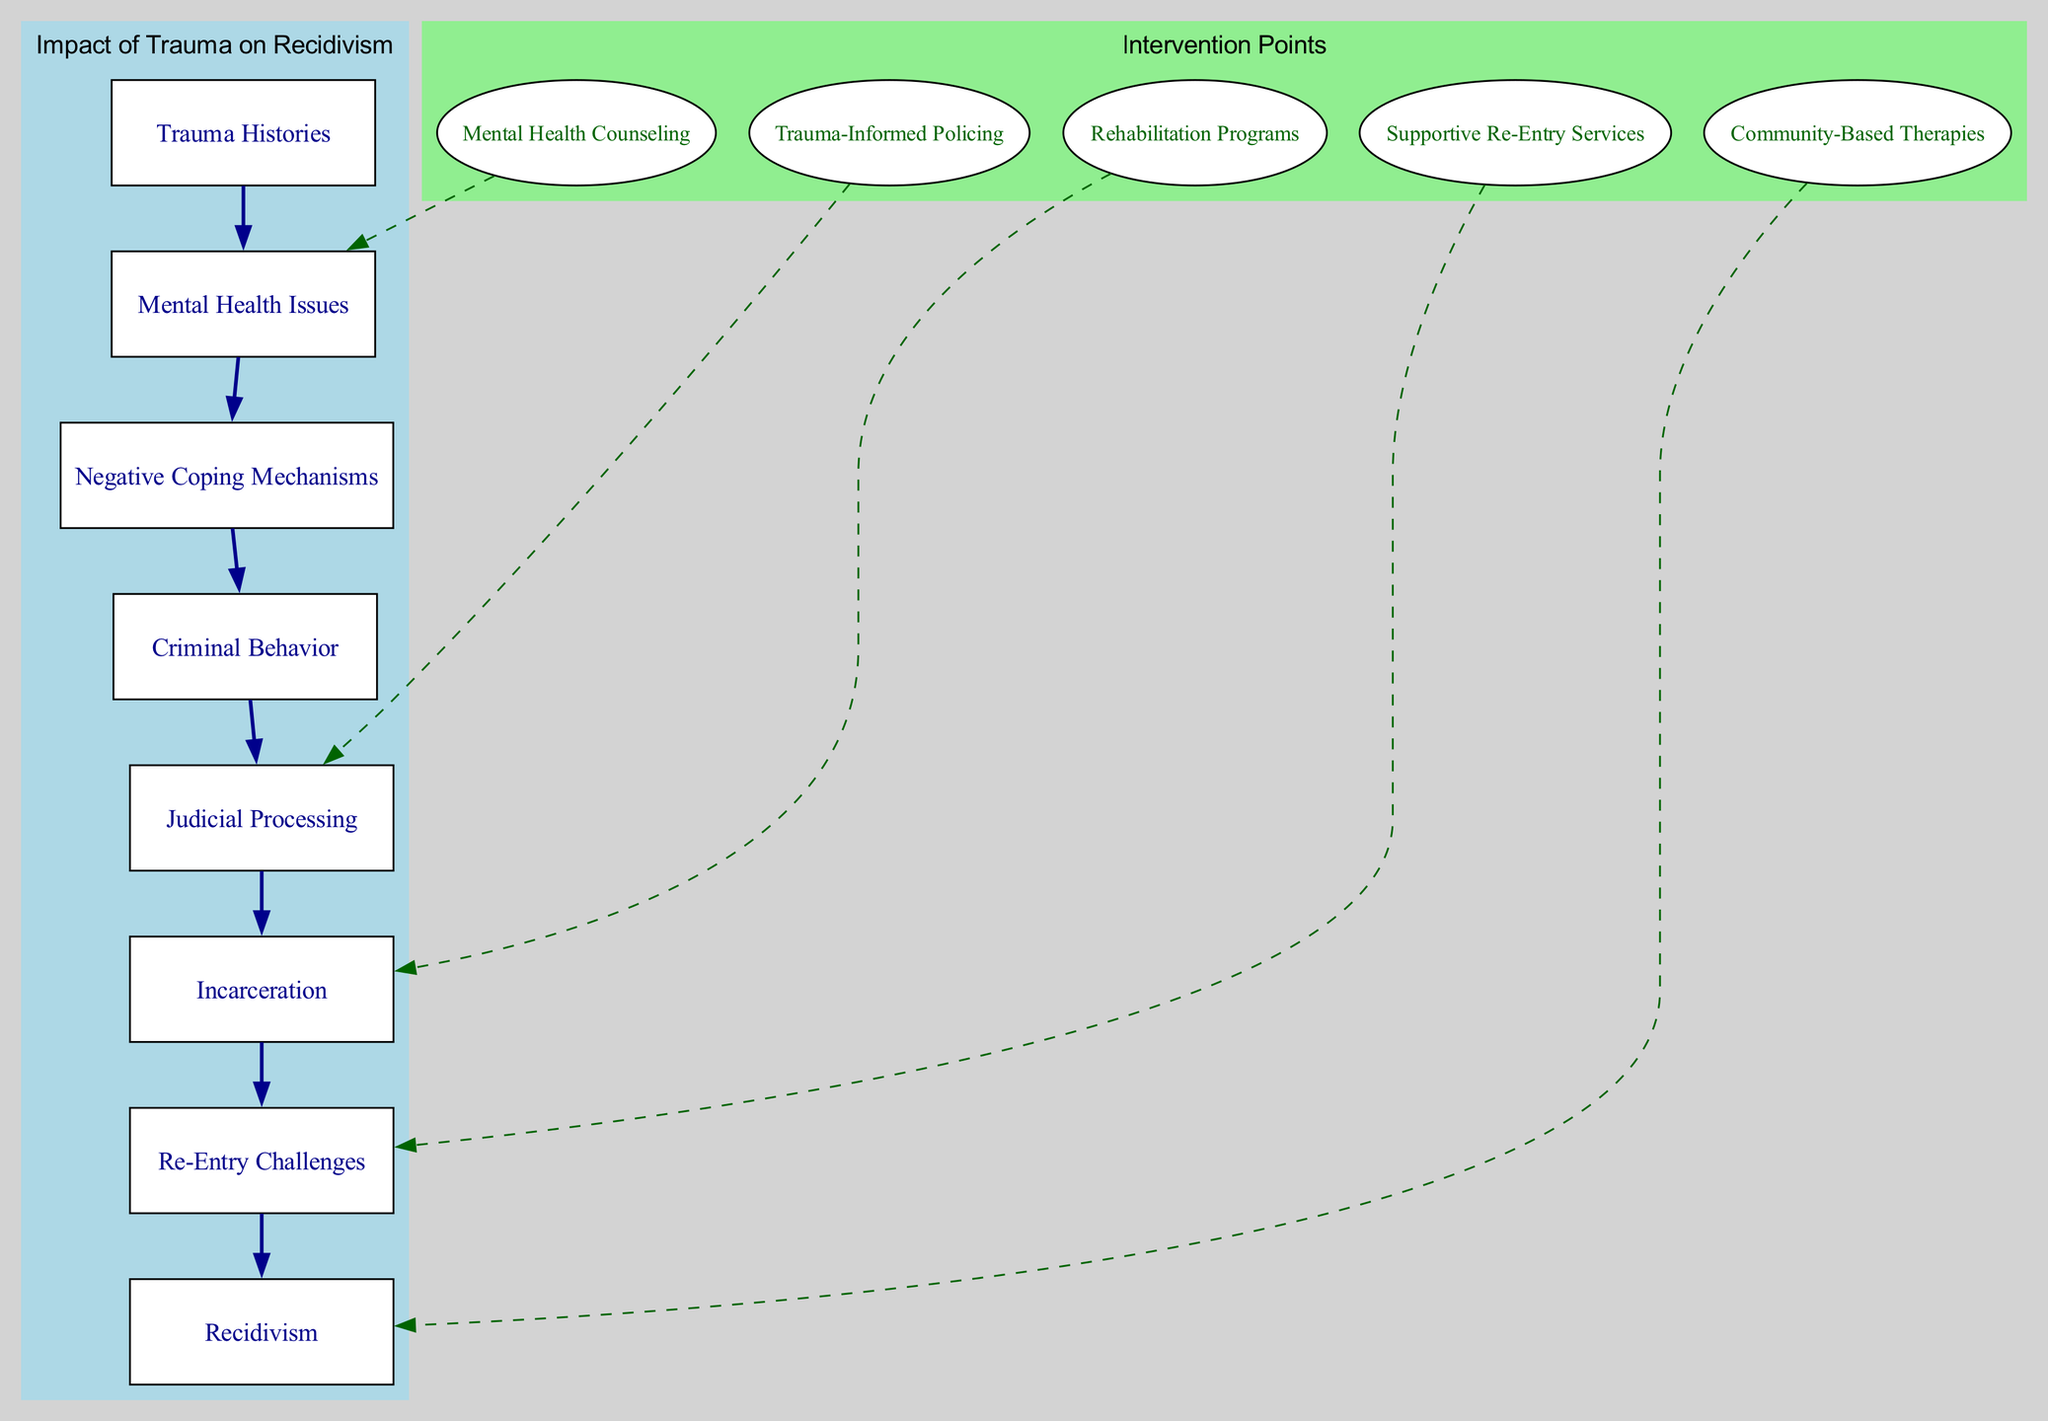What is the first block in the diagram? The first block listed is "Trauma Histories," which is the starting point of the pathway leading towards recidivism. It's labeled at the top of the main cluster in the block diagram.
Answer: Trauma Histories What connects "Trauma Histories" to "Mental Health Issues"? The connection between "Trauma Histories" and "Mental Health Issues" is represented by a dark blue edge, indicating a direct flow or influence that trauma has on mental health challenges.
Answer: A dark blue edge How many intervention points are shown in the diagram? There are five intervention points listed under the "Intervention Points" block, representing various approaches to address the impact of trauma on recidivism.
Answer: Five Which intervention point connects to "Judicial Processing"? "Trauma-Informed Policing" connects to "Judicial Processing" through a dashed edge, suggesting a relationship where trauma-informed practices can influence how individuals are processed in the judicial system.
Answer: Trauma-Informed Policing What block comes before "Criminal Behavior"? "Negative Coping Mechanisms" is the block that comes just before "Criminal Behavior," indicating a progression where negative coping results in increased criminal chances.
Answer: Negative Coping Mechanisms What are the final outcomes linked to "Re-Entry Challenges"? "Recidivism" is the final outcome tied directly to the "Re-Entry Challenges" block in the flow of the diagram, emphasizing the link between struggles after release and the likelihood of re-offending.
Answer: Recidivism How does “Mental Health Issues” influence “Criminal Behavior”? "Mental Health Issues" directly influences "Criminal Behavior" as indicated by the dark blue edge connecting the two blocks, highlighting that unresolved mental health challenges can lead to criminal acts.
Answer: Through a dark blue edge Which block indicates the potential for re-traumatization during incarceration? "Incarceration" is the block that highlights the potential for re-traumatization as individuals are confined in prisons or detention centers, often aggravating their trauma experiences.
Answer: Incarceration What do the dashed edges represent in the intervention points? The dashed edges signify indirect connections where interventions could potentially address, alter, or improve pathways leading to recidivism within the broader systems.
Answer: Indirect connections 